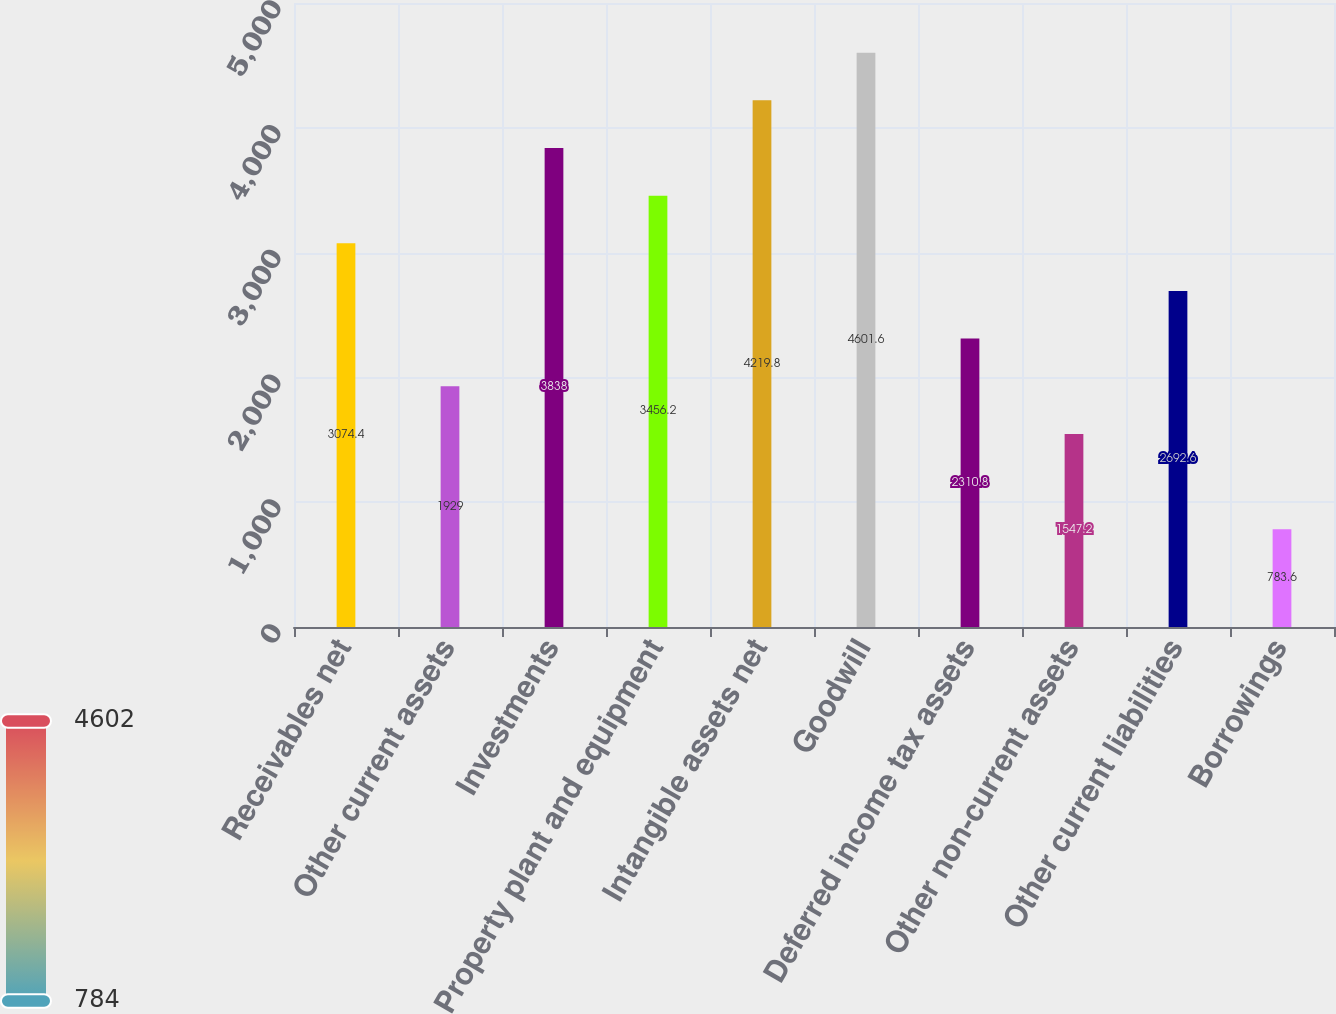<chart> <loc_0><loc_0><loc_500><loc_500><bar_chart><fcel>Receivables net<fcel>Other current assets<fcel>Investments<fcel>Property plant and equipment<fcel>Intangible assets net<fcel>Goodwill<fcel>Deferred income tax assets<fcel>Other non-current assets<fcel>Other current liabilities<fcel>Borrowings<nl><fcel>3074.4<fcel>1929<fcel>3838<fcel>3456.2<fcel>4219.8<fcel>4601.6<fcel>2310.8<fcel>1547.2<fcel>2692.6<fcel>783.6<nl></chart> 